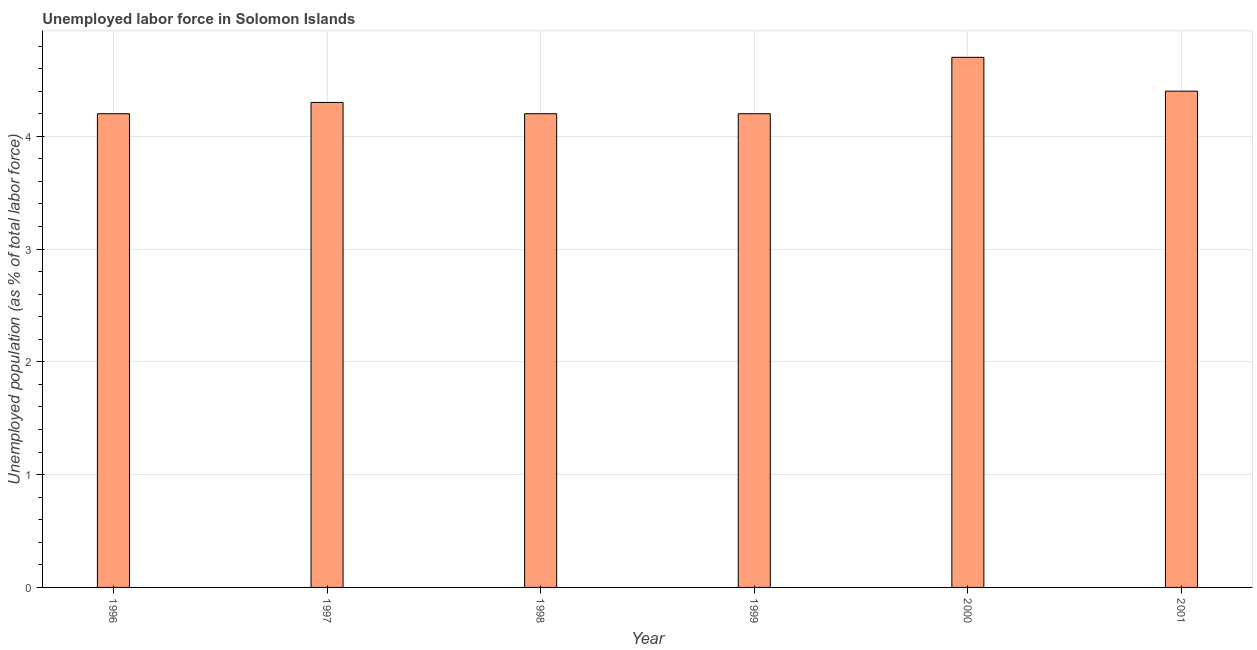What is the title of the graph?
Ensure brevity in your answer.  Unemployed labor force in Solomon Islands. What is the label or title of the X-axis?
Your answer should be compact. Year. What is the label or title of the Y-axis?
Keep it short and to the point. Unemployed population (as % of total labor force). What is the total unemployed population in 2000?
Your response must be concise. 4.7. Across all years, what is the maximum total unemployed population?
Keep it short and to the point. 4.7. Across all years, what is the minimum total unemployed population?
Keep it short and to the point. 4.2. In which year was the total unemployed population maximum?
Your answer should be compact. 2000. In which year was the total unemployed population minimum?
Your answer should be very brief. 1996. What is the sum of the total unemployed population?
Offer a very short reply. 26. What is the average total unemployed population per year?
Your answer should be compact. 4.33. What is the median total unemployed population?
Offer a very short reply. 4.25. In how many years, is the total unemployed population greater than 3.4 %?
Your answer should be compact. 6. Do a majority of the years between 2000 and 2001 (inclusive) have total unemployed population greater than 0.6 %?
Provide a succinct answer. Yes. Is the difference between the total unemployed population in 1996 and 1999 greater than the difference between any two years?
Your answer should be very brief. No. What is the difference between the highest and the second highest total unemployed population?
Give a very brief answer. 0.3. Is the sum of the total unemployed population in 1997 and 2000 greater than the maximum total unemployed population across all years?
Make the answer very short. Yes. In how many years, is the total unemployed population greater than the average total unemployed population taken over all years?
Offer a very short reply. 2. How many years are there in the graph?
Offer a terse response. 6. What is the difference between two consecutive major ticks on the Y-axis?
Keep it short and to the point. 1. What is the Unemployed population (as % of total labor force) of 1996?
Offer a terse response. 4.2. What is the Unemployed population (as % of total labor force) of 1997?
Keep it short and to the point. 4.3. What is the Unemployed population (as % of total labor force) of 1998?
Your answer should be compact. 4.2. What is the Unemployed population (as % of total labor force) in 1999?
Your response must be concise. 4.2. What is the Unemployed population (as % of total labor force) in 2000?
Make the answer very short. 4.7. What is the Unemployed population (as % of total labor force) of 2001?
Offer a terse response. 4.4. What is the difference between the Unemployed population (as % of total labor force) in 1996 and 1998?
Your answer should be compact. 0. What is the difference between the Unemployed population (as % of total labor force) in 1996 and 1999?
Your answer should be compact. 0. What is the difference between the Unemployed population (as % of total labor force) in 1996 and 2001?
Ensure brevity in your answer.  -0.2. What is the difference between the Unemployed population (as % of total labor force) in 1997 and 1999?
Your answer should be compact. 0.1. What is the difference between the Unemployed population (as % of total labor force) in 1998 and 1999?
Provide a succinct answer. 0. What is the difference between the Unemployed population (as % of total labor force) in 1999 and 2000?
Your answer should be compact. -0.5. What is the difference between the Unemployed population (as % of total labor force) in 2000 and 2001?
Provide a succinct answer. 0.3. What is the ratio of the Unemployed population (as % of total labor force) in 1996 to that in 1997?
Provide a succinct answer. 0.98. What is the ratio of the Unemployed population (as % of total labor force) in 1996 to that in 1998?
Offer a very short reply. 1. What is the ratio of the Unemployed population (as % of total labor force) in 1996 to that in 2000?
Provide a succinct answer. 0.89. What is the ratio of the Unemployed population (as % of total labor force) in 1996 to that in 2001?
Keep it short and to the point. 0.95. What is the ratio of the Unemployed population (as % of total labor force) in 1997 to that in 1999?
Offer a very short reply. 1.02. What is the ratio of the Unemployed population (as % of total labor force) in 1997 to that in 2000?
Offer a very short reply. 0.92. What is the ratio of the Unemployed population (as % of total labor force) in 1997 to that in 2001?
Your answer should be very brief. 0.98. What is the ratio of the Unemployed population (as % of total labor force) in 1998 to that in 1999?
Your answer should be very brief. 1. What is the ratio of the Unemployed population (as % of total labor force) in 1998 to that in 2000?
Make the answer very short. 0.89. What is the ratio of the Unemployed population (as % of total labor force) in 1998 to that in 2001?
Provide a short and direct response. 0.95. What is the ratio of the Unemployed population (as % of total labor force) in 1999 to that in 2000?
Your answer should be compact. 0.89. What is the ratio of the Unemployed population (as % of total labor force) in 1999 to that in 2001?
Make the answer very short. 0.95. What is the ratio of the Unemployed population (as % of total labor force) in 2000 to that in 2001?
Offer a very short reply. 1.07. 